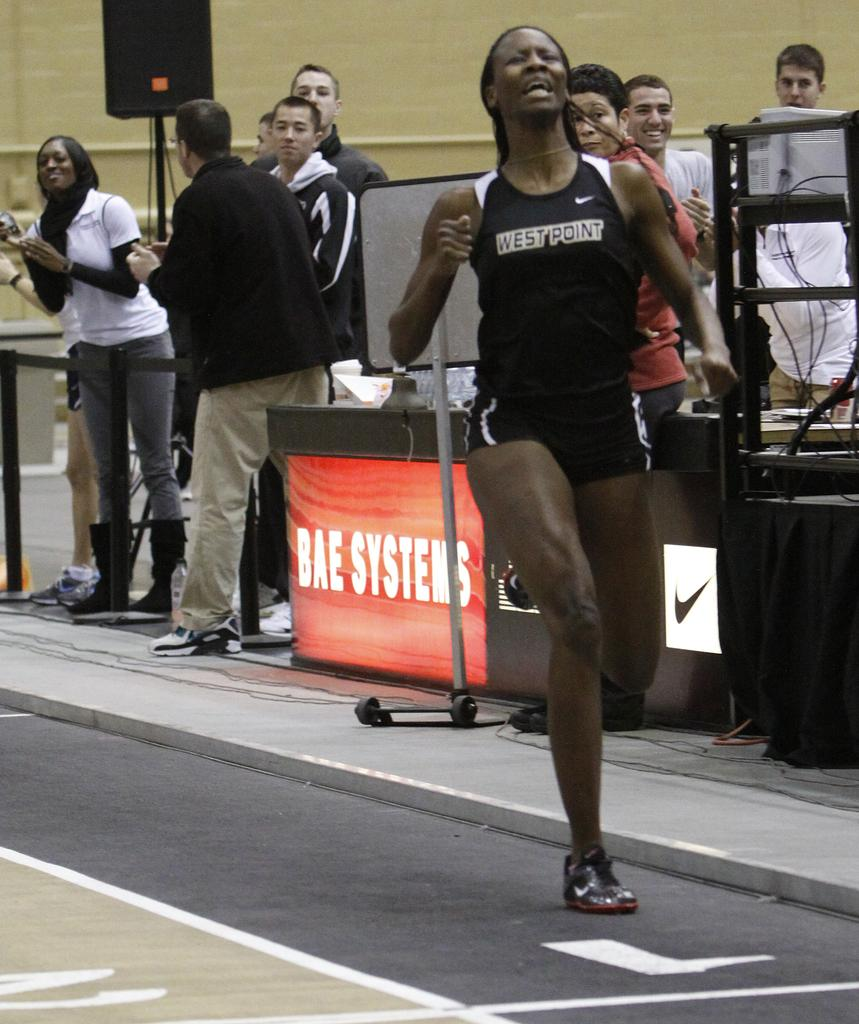What is happening in the image involving people? There are people standing in the image. What can be seen on the table in the image? There are objects on a table in the image. What is the purpose of the speaker in the image? There is a speaker in the image, which is typically used for amplifying sound. What is the stand in the image used for? There is a stand in the image, which could be used to support or display objects. What is the background of the image? There is a wall in the image, which serves as the background. What type of fear can be seen on the faces of the people in the image? There is no indication of fear on the faces of the people in the image. How many clocks are visible on the wall in the image? There is no mention of clocks in the image; only a wall is mentioned. What is the size of the bit in the image? There is no bit present in the image. 